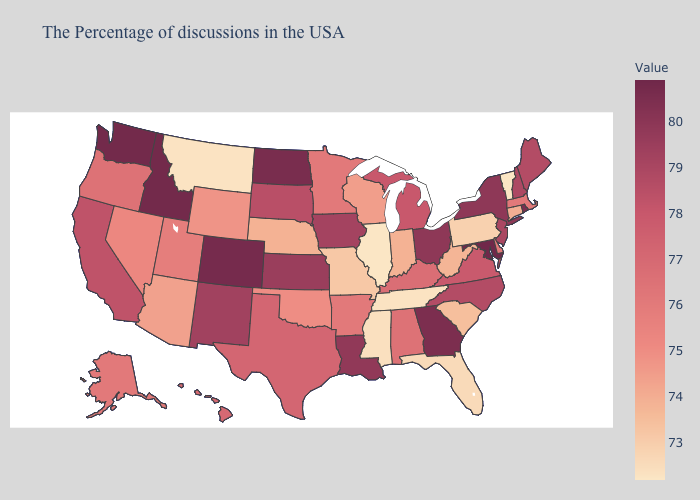Does Delaware have the highest value in the USA?
Give a very brief answer. No. Does Rhode Island have the highest value in the Northeast?
Keep it brief. Yes. Which states have the lowest value in the USA?
Write a very short answer. Vermont, Illinois. 